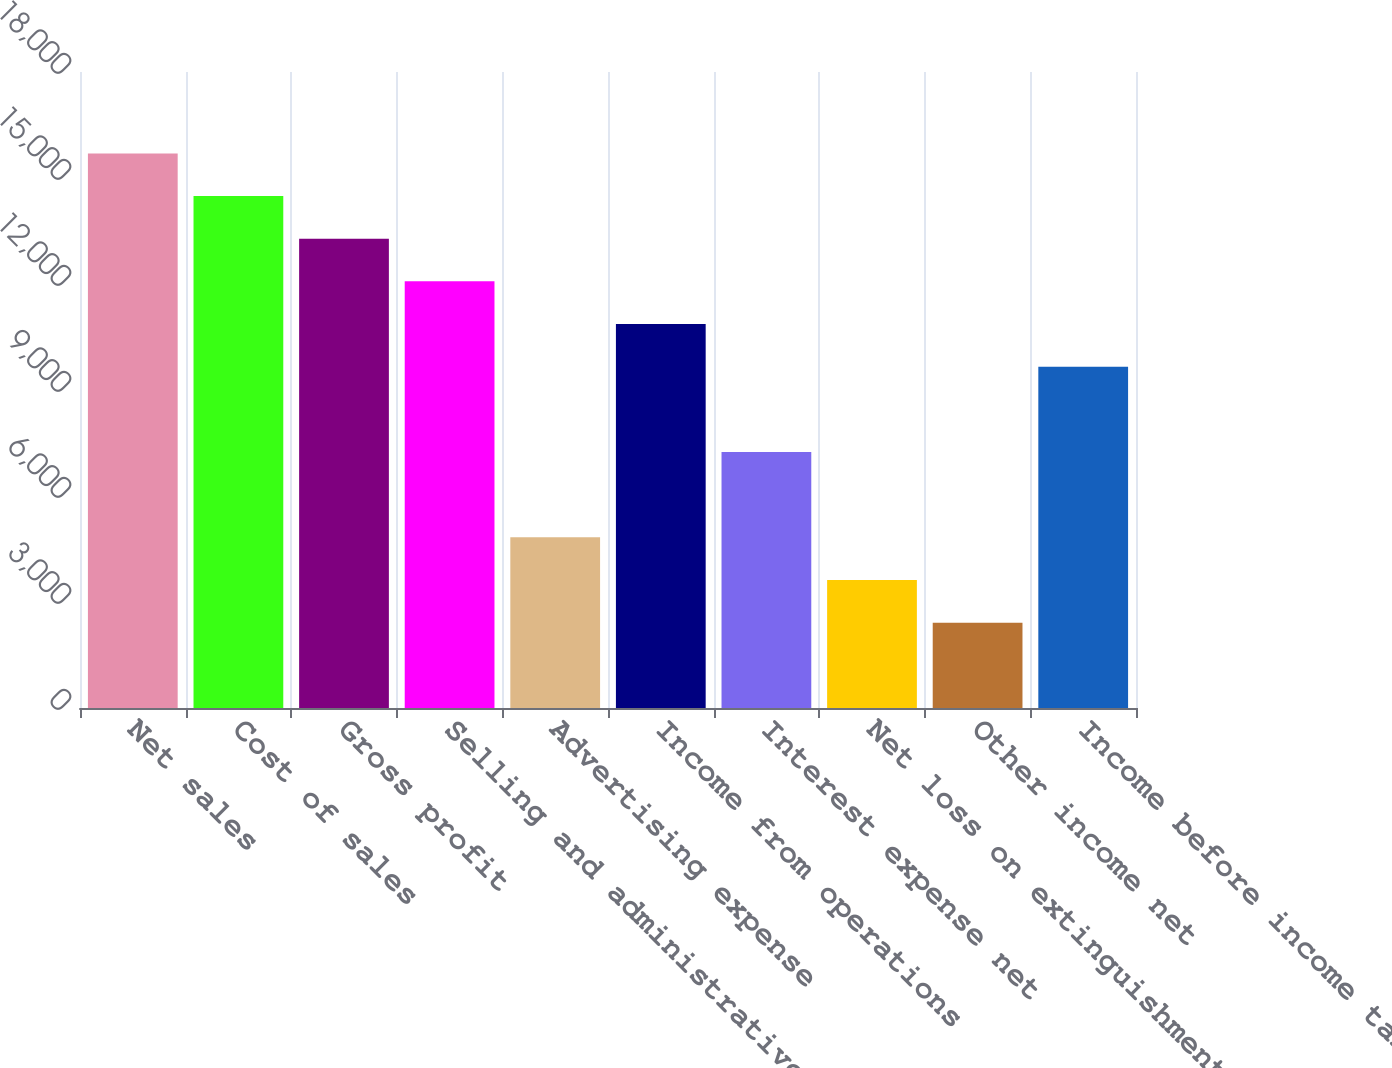Convert chart. <chart><loc_0><loc_0><loc_500><loc_500><bar_chart><fcel>Net sales<fcel>Cost of sales<fcel>Gross profit<fcel>Selling and administrative<fcel>Advertising expense<fcel>Income from operations<fcel>Interest expense net<fcel>Net loss on extinguishments of<fcel>Other income net<fcel>Income before income taxes<nl><fcel>15696.5<fcel>14489.1<fcel>13281.8<fcel>12074.5<fcel>4830.66<fcel>10867.2<fcel>7245.28<fcel>3623.35<fcel>2416.04<fcel>9659.9<nl></chart> 